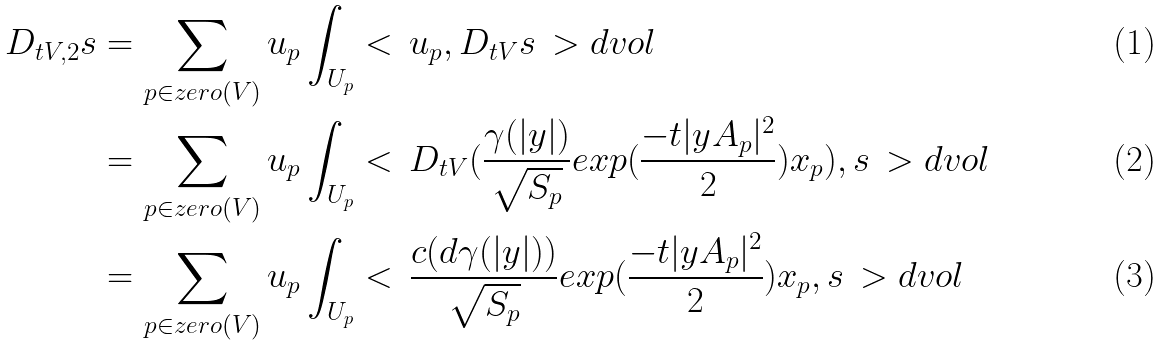Convert formula to latex. <formula><loc_0><loc_0><loc_500><loc_500>D _ { t V , 2 } s & = \sum _ { p \in z e r o ( V ) } u _ { p } \int _ { U _ { p } } < \, u _ { p } , D _ { t V } s \, > d v o l \\ & = \sum _ { p \in z e r o ( V ) } u _ { p } \int _ { U _ { p } } < \, D _ { t V } ( \frac { \gamma ( | y | ) } { \sqrt { S _ { p } } } e x p ( \frac { - t | y A _ { p } | ^ { 2 } } { 2 } ) x _ { p } ) , s \, > d v o l \\ & = \sum _ { p \in z e r o ( V ) } u _ { p } \int _ { U _ { p } } < \, \frac { c ( d \gamma ( | y | ) ) } { \sqrt { S _ { p } } } e x p ( \frac { - t | y A _ { p } | ^ { 2 } } { 2 } ) x _ { p } , s \, > d v o l</formula> 